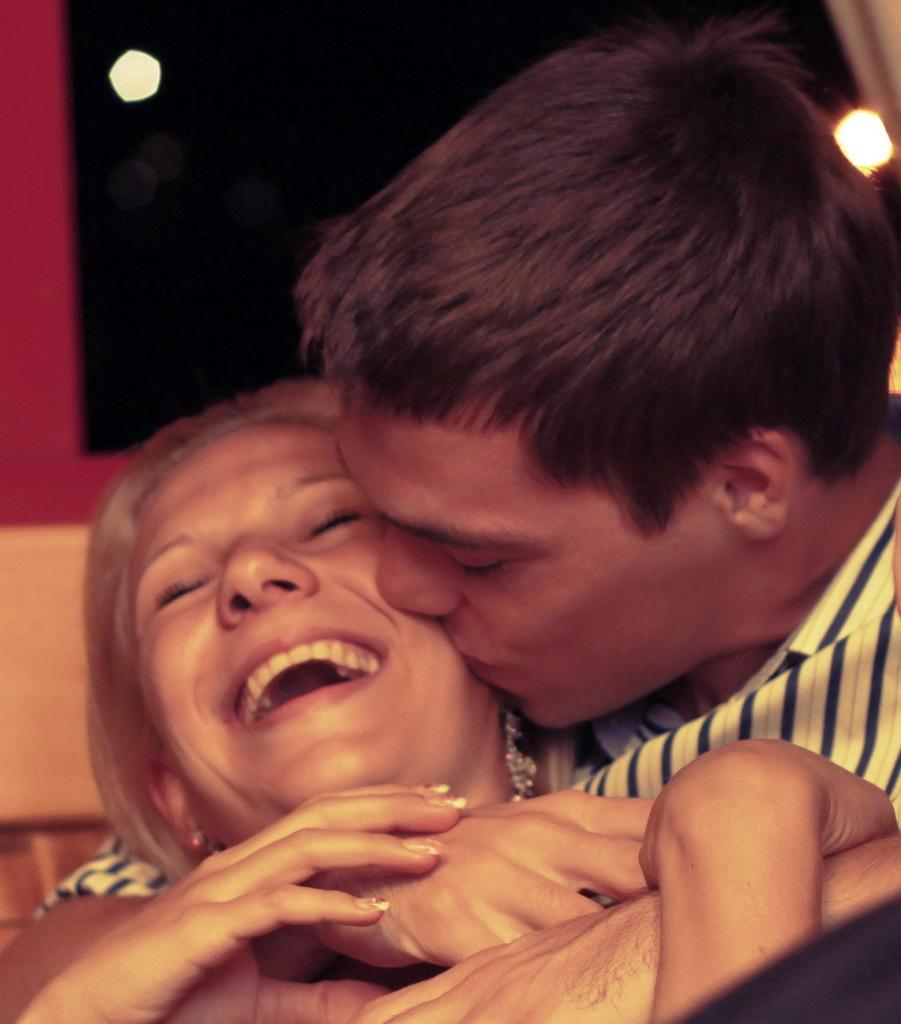Who are the people in the image? There is a man and a woman in the image. What is the man doing to the woman? The man is kissing the woman. How does the woman feel about the man's action? The woman is smiling, which suggests she is happy or enjoying the moment. What can be seen in the background of the image? There are lights and a wall in the background of the image. What type of net can be seen catching the woman's voice in the image? There is no net or any reference to a voice in the image; it simply shows a man kissing a woman with lights and a wall in the background. 